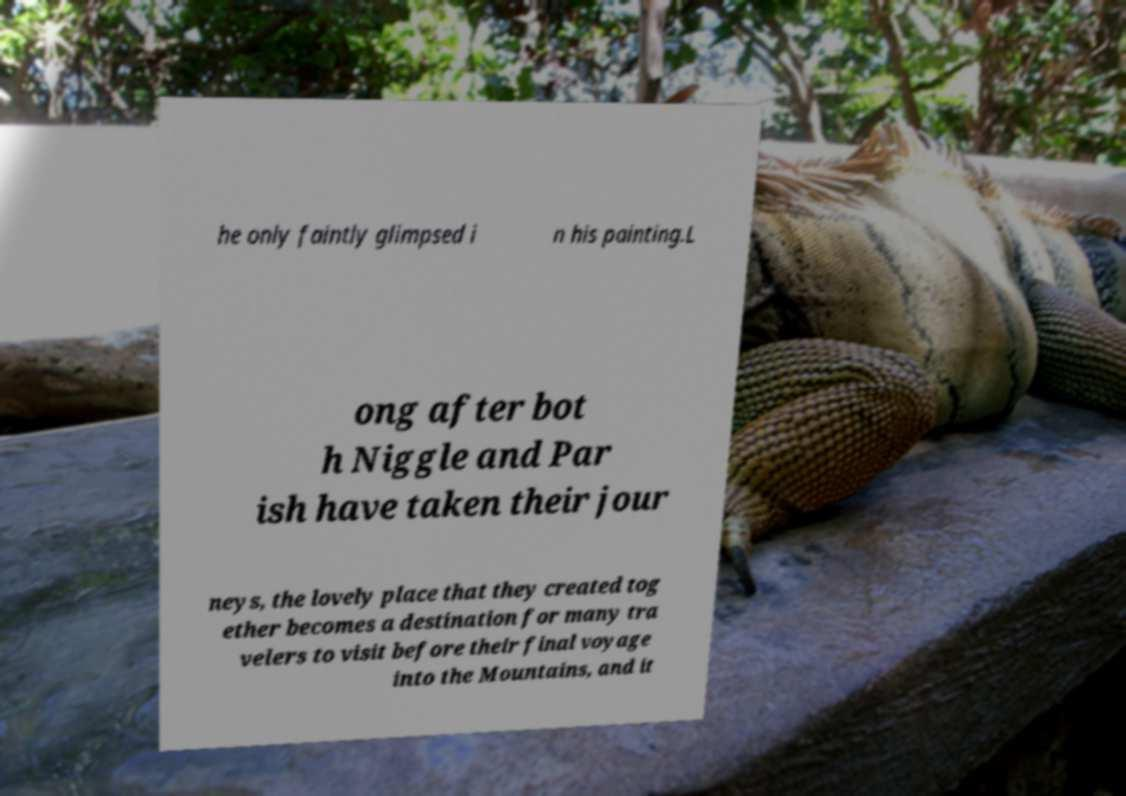Could you extract and type out the text from this image? he only faintly glimpsed i n his painting.L ong after bot h Niggle and Par ish have taken their jour neys, the lovely place that they created tog ether becomes a destination for many tra velers to visit before their final voyage into the Mountains, and it 